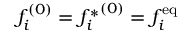Convert formula to latex. <formula><loc_0><loc_0><loc_500><loc_500>f _ { i } ^ { ( 0 ) } = { f _ { i } ^ { * } } ^ { ( 0 ) } = f _ { i } ^ { e q }</formula> 